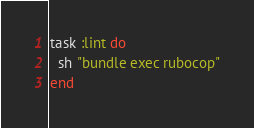<code> <loc_0><loc_0><loc_500><loc_500><_Ruby_>task :lint do
  sh "bundle exec rubocop"
end
</code> 